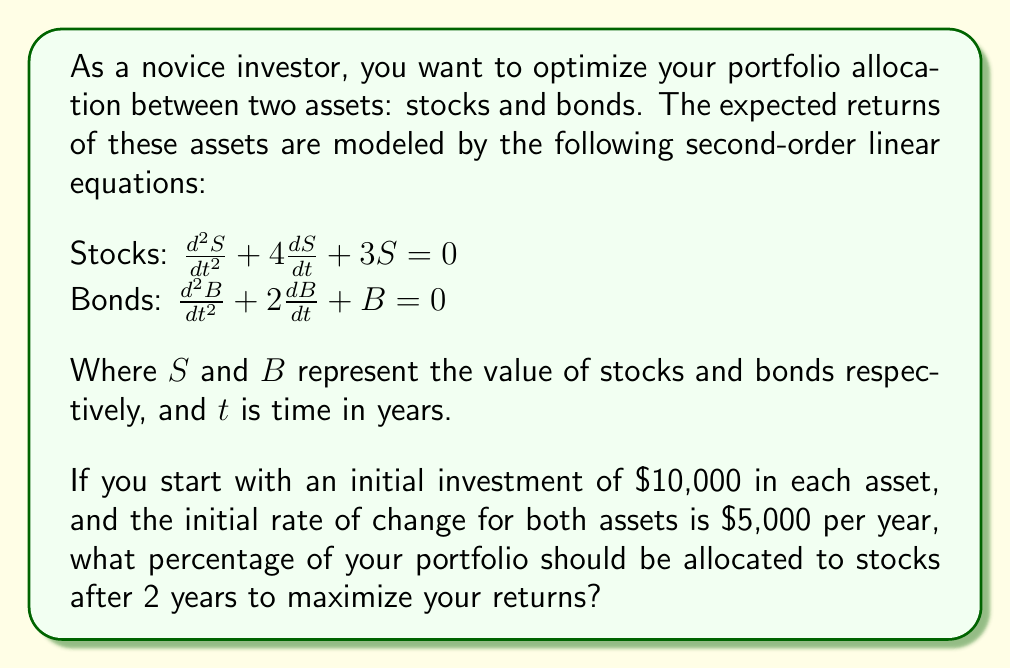Show me your answer to this math problem. To solve this problem, we need to follow these steps:

1) First, we need to solve the second-order linear equations for both stocks and bonds.

2) For stocks: $\frac{d^2S}{dt^2} + 4\frac{dS}{dt} + 3S = 0$
   The characteristic equation is: $r^2 + 4r + 3 = 0$
   Solving this, we get: $r = -1$ or $r = -3$
   So, the general solution is: $S(t) = C_1e^{-t} + C_2e^{-3t}$

3) For bonds: $\frac{d^2B}{dt^2} + 2\frac{dB}{dt} + B = 0$
   The characteristic equation is: $r^2 + 2r + 1 = 0$
   Solving this, we get: $r = -1$ (repeated root)
   So, the general solution is: $B(t) = (C_3 + C_4t)e^{-t}$

4) Now, we use the initial conditions to find the constants:
   At $t = 0$, $S(0) = 10,000$ and $\frac{dS}{dt}(0) = 5,000$
   At $t = 0$, $B(0) = 10,000$ and $\frac{dB}{dt}(0) = 5,000$

5) For stocks:
   $S(0) = C_1 + C_2 = 10,000$
   $S'(0) = -C_1 - 3C_2 = 5,000$
   Solving these equations, we get: $C_1 = 17,500$ and $C_2 = -7,500$

6) For bonds:
   $B(0) = C_3 = 10,000$
   $B'(0) = C_4 - C_3 = 5,000$
   Solving these equations, we get: $C_3 = 10,000$ and $C_4 = 15,000$

7) Now we can write the particular solutions:
   $S(t) = 17,500e^{-t} - 7,500e^{-3t}$
   $B(t) = (10,000 + 15,000t)e^{-t}$

8) To find the values after 2 years, we substitute $t = 2$:
   $S(2) = 17,500e^{-2} - 7,500e^{-6} \approx 2,357.02$
   $B(2) = (10,000 + 30,000)e^{-2} \approx 5,413.41$

9) The total portfolio value after 2 years is: $2,357.02 + 5,413.41 = 7,770.43$

10) The percentage allocated to stocks is:
    $\frac{2,357.02}{7,770.43} \times 100\% \approx 30.33\%$
Answer: To maximize returns after 2 years, approximately 30.33% of the portfolio should be allocated to stocks. 